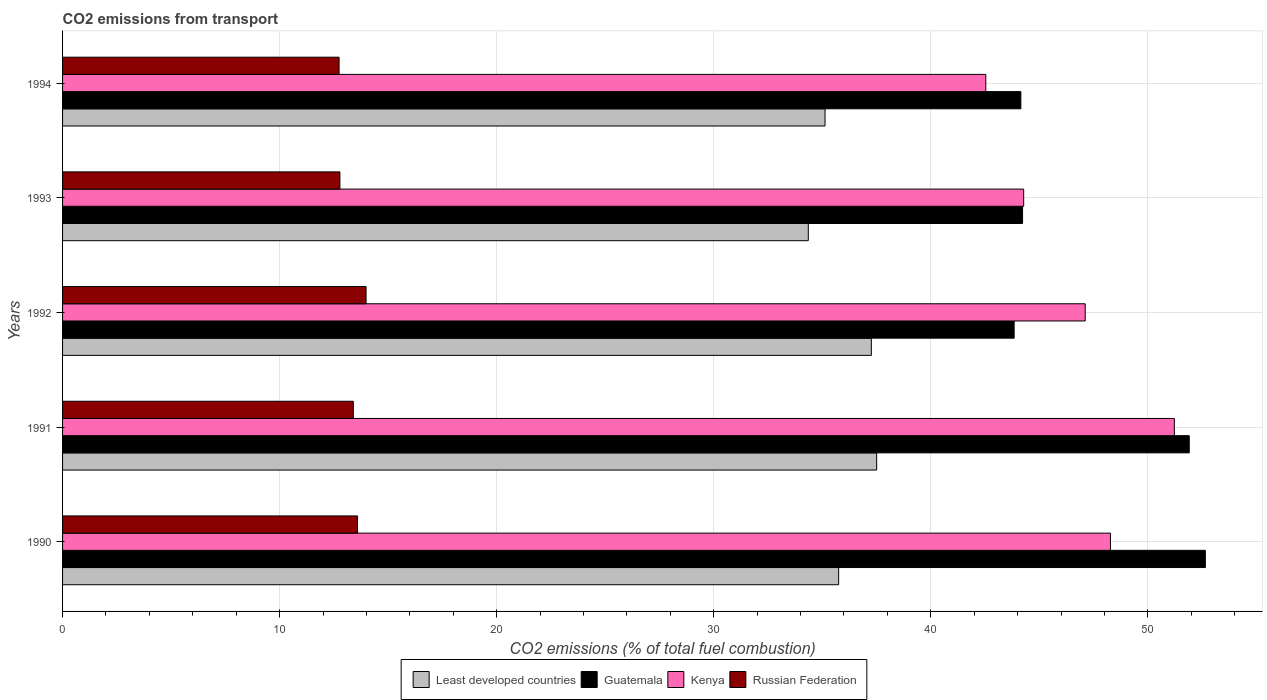How many bars are there on the 1st tick from the top?
Provide a succinct answer. 4. In how many cases, is the number of bars for a given year not equal to the number of legend labels?
Give a very brief answer. 0. What is the total CO2 emitted in Least developed countries in 1990?
Provide a succinct answer. 35.75. Across all years, what is the maximum total CO2 emitted in Guatemala?
Your answer should be compact. 52.65. Across all years, what is the minimum total CO2 emitted in Least developed countries?
Give a very brief answer. 34.36. What is the total total CO2 emitted in Guatemala in the graph?
Offer a terse response. 236.77. What is the difference between the total CO2 emitted in Russian Federation in 1991 and that in 1994?
Make the answer very short. 0.66. What is the difference between the total CO2 emitted in Guatemala in 1992 and the total CO2 emitted in Kenya in 1993?
Your response must be concise. -0.44. What is the average total CO2 emitted in Least developed countries per year?
Provide a short and direct response. 36. In the year 1994, what is the difference between the total CO2 emitted in Kenya and total CO2 emitted in Russian Federation?
Your response must be concise. 29.79. What is the ratio of the total CO2 emitted in Kenya in 1991 to that in 1993?
Offer a very short reply. 1.16. Is the difference between the total CO2 emitted in Kenya in 1990 and 1992 greater than the difference between the total CO2 emitted in Russian Federation in 1990 and 1992?
Your response must be concise. Yes. What is the difference between the highest and the second highest total CO2 emitted in Guatemala?
Keep it short and to the point. 0.74. What is the difference between the highest and the lowest total CO2 emitted in Kenya?
Your answer should be compact. 8.69. Is the sum of the total CO2 emitted in Russian Federation in 1991 and 1994 greater than the maximum total CO2 emitted in Guatemala across all years?
Your answer should be very brief. No. Is it the case that in every year, the sum of the total CO2 emitted in Russian Federation and total CO2 emitted in Least developed countries is greater than the sum of total CO2 emitted in Guatemala and total CO2 emitted in Kenya?
Keep it short and to the point. Yes. What does the 3rd bar from the top in 1990 represents?
Your answer should be compact. Guatemala. What does the 1st bar from the bottom in 1992 represents?
Make the answer very short. Least developed countries. Is it the case that in every year, the sum of the total CO2 emitted in Kenya and total CO2 emitted in Least developed countries is greater than the total CO2 emitted in Guatemala?
Your answer should be compact. Yes. How many bars are there?
Keep it short and to the point. 20. Are all the bars in the graph horizontal?
Give a very brief answer. Yes. What is the difference between two consecutive major ticks on the X-axis?
Make the answer very short. 10. Does the graph contain any zero values?
Make the answer very short. No. How many legend labels are there?
Provide a succinct answer. 4. What is the title of the graph?
Offer a terse response. CO2 emissions from transport. What is the label or title of the X-axis?
Your answer should be compact. CO2 emissions (% of total fuel combustion). What is the label or title of the Y-axis?
Provide a short and direct response. Years. What is the CO2 emissions (% of total fuel combustion) in Least developed countries in 1990?
Give a very brief answer. 35.75. What is the CO2 emissions (% of total fuel combustion) in Guatemala in 1990?
Offer a very short reply. 52.65. What is the CO2 emissions (% of total fuel combustion) of Kenya in 1990?
Your answer should be very brief. 48.28. What is the CO2 emissions (% of total fuel combustion) of Russian Federation in 1990?
Your response must be concise. 13.59. What is the CO2 emissions (% of total fuel combustion) in Least developed countries in 1991?
Make the answer very short. 37.51. What is the CO2 emissions (% of total fuel combustion) in Guatemala in 1991?
Provide a short and direct response. 51.91. What is the CO2 emissions (% of total fuel combustion) of Kenya in 1991?
Your answer should be very brief. 51.22. What is the CO2 emissions (% of total fuel combustion) of Russian Federation in 1991?
Offer a very short reply. 13.4. What is the CO2 emissions (% of total fuel combustion) of Least developed countries in 1992?
Give a very brief answer. 37.26. What is the CO2 emissions (% of total fuel combustion) in Guatemala in 1992?
Your response must be concise. 43.84. What is the CO2 emissions (% of total fuel combustion) in Kenya in 1992?
Provide a short and direct response. 47.11. What is the CO2 emissions (% of total fuel combustion) of Russian Federation in 1992?
Keep it short and to the point. 13.98. What is the CO2 emissions (% of total fuel combustion) of Least developed countries in 1993?
Make the answer very short. 34.36. What is the CO2 emissions (% of total fuel combustion) of Guatemala in 1993?
Your answer should be compact. 44.23. What is the CO2 emissions (% of total fuel combustion) in Kenya in 1993?
Keep it short and to the point. 44.28. What is the CO2 emissions (% of total fuel combustion) of Russian Federation in 1993?
Your response must be concise. 12.78. What is the CO2 emissions (% of total fuel combustion) in Least developed countries in 1994?
Offer a terse response. 35.13. What is the CO2 emissions (% of total fuel combustion) in Guatemala in 1994?
Your answer should be compact. 44.15. What is the CO2 emissions (% of total fuel combustion) of Kenya in 1994?
Make the answer very short. 42.53. What is the CO2 emissions (% of total fuel combustion) of Russian Federation in 1994?
Offer a terse response. 12.74. Across all years, what is the maximum CO2 emissions (% of total fuel combustion) of Least developed countries?
Your answer should be very brief. 37.51. Across all years, what is the maximum CO2 emissions (% of total fuel combustion) of Guatemala?
Offer a very short reply. 52.65. Across all years, what is the maximum CO2 emissions (% of total fuel combustion) in Kenya?
Provide a short and direct response. 51.22. Across all years, what is the maximum CO2 emissions (% of total fuel combustion) of Russian Federation?
Give a very brief answer. 13.98. Across all years, what is the minimum CO2 emissions (% of total fuel combustion) in Least developed countries?
Provide a short and direct response. 34.36. Across all years, what is the minimum CO2 emissions (% of total fuel combustion) of Guatemala?
Make the answer very short. 43.84. Across all years, what is the minimum CO2 emissions (% of total fuel combustion) in Kenya?
Offer a very short reply. 42.53. Across all years, what is the minimum CO2 emissions (% of total fuel combustion) in Russian Federation?
Ensure brevity in your answer.  12.74. What is the total CO2 emissions (% of total fuel combustion) in Least developed countries in the graph?
Your answer should be very brief. 180. What is the total CO2 emissions (% of total fuel combustion) in Guatemala in the graph?
Provide a short and direct response. 236.77. What is the total CO2 emissions (% of total fuel combustion) in Kenya in the graph?
Offer a very short reply. 233.42. What is the total CO2 emissions (% of total fuel combustion) in Russian Federation in the graph?
Your answer should be very brief. 66.48. What is the difference between the CO2 emissions (% of total fuel combustion) of Least developed countries in 1990 and that in 1991?
Your answer should be very brief. -1.75. What is the difference between the CO2 emissions (% of total fuel combustion) of Guatemala in 1990 and that in 1991?
Keep it short and to the point. 0.74. What is the difference between the CO2 emissions (% of total fuel combustion) of Kenya in 1990 and that in 1991?
Your answer should be compact. -2.94. What is the difference between the CO2 emissions (% of total fuel combustion) of Russian Federation in 1990 and that in 1991?
Offer a terse response. 0.19. What is the difference between the CO2 emissions (% of total fuel combustion) in Least developed countries in 1990 and that in 1992?
Offer a terse response. -1.51. What is the difference between the CO2 emissions (% of total fuel combustion) in Guatemala in 1990 and that in 1992?
Your answer should be very brief. 8.81. What is the difference between the CO2 emissions (% of total fuel combustion) in Kenya in 1990 and that in 1992?
Your answer should be compact. 1.16. What is the difference between the CO2 emissions (% of total fuel combustion) of Russian Federation in 1990 and that in 1992?
Give a very brief answer. -0.39. What is the difference between the CO2 emissions (% of total fuel combustion) in Least developed countries in 1990 and that in 1993?
Your answer should be compact. 1.4. What is the difference between the CO2 emissions (% of total fuel combustion) in Guatemala in 1990 and that in 1993?
Your answer should be very brief. 8.42. What is the difference between the CO2 emissions (% of total fuel combustion) of Kenya in 1990 and that in 1993?
Your answer should be very brief. 4. What is the difference between the CO2 emissions (% of total fuel combustion) of Russian Federation in 1990 and that in 1993?
Keep it short and to the point. 0.81. What is the difference between the CO2 emissions (% of total fuel combustion) in Least developed countries in 1990 and that in 1994?
Offer a very short reply. 0.63. What is the difference between the CO2 emissions (% of total fuel combustion) in Guatemala in 1990 and that in 1994?
Make the answer very short. 8.5. What is the difference between the CO2 emissions (% of total fuel combustion) of Kenya in 1990 and that in 1994?
Make the answer very short. 5.74. What is the difference between the CO2 emissions (% of total fuel combustion) of Russian Federation in 1990 and that in 1994?
Give a very brief answer. 0.85. What is the difference between the CO2 emissions (% of total fuel combustion) in Least developed countries in 1991 and that in 1992?
Give a very brief answer. 0.24. What is the difference between the CO2 emissions (% of total fuel combustion) of Guatemala in 1991 and that in 1992?
Ensure brevity in your answer.  8.07. What is the difference between the CO2 emissions (% of total fuel combustion) of Kenya in 1991 and that in 1992?
Offer a terse response. 4.11. What is the difference between the CO2 emissions (% of total fuel combustion) in Russian Federation in 1991 and that in 1992?
Offer a terse response. -0.59. What is the difference between the CO2 emissions (% of total fuel combustion) of Least developed countries in 1991 and that in 1993?
Keep it short and to the point. 3.15. What is the difference between the CO2 emissions (% of total fuel combustion) in Guatemala in 1991 and that in 1993?
Your response must be concise. 7.68. What is the difference between the CO2 emissions (% of total fuel combustion) in Kenya in 1991 and that in 1993?
Make the answer very short. 6.94. What is the difference between the CO2 emissions (% of total fuel combustion) in Russian Federation in 1991 and that in 1993?
Provide a short and direct response. 0.62. What is the difference between the CO2 emissions (% of total fuel combustion) in Least developed countries in 1991 and that in 1994?
Provide a short and direct response. 2.38. What is the difference between the CO2 emissions (% of total fuel combustion) of Guatemala in 1991 and that in 1994?
Your answer should be compact. 7.76. What is the difference between the CO2 emissions (% of total fuel combustion) of Kenya in 1991 and that in 1994?
Make the answer very short. 8.69. What is the difference between the CO2 emissions (% of total fuel combustion) of Russian Federation in 1991 and that in 1994?
Offer a terse response. 0.66. What is the difference between the CO2 emissions (% of total fuel combustion) in Least developed countries in 1992 and that in 1993?
Offer a very short reply. 2.91. What is the difference between the CO2 emissions (% of total fuel combustion) of Guatemala in 1992 and that in 1993?
Provide a succinct answer. -0.39. What is the difference between the CO2 emissions (% of total fuel combustion) of Kenya in 1992 and that in 1993?
Provide a short and direct response. 2.84. What is the difference between the CO2 emissions (% of total fuel combustion) in Russian Federation in 1992 and that in 1993?
Keep it short and to the point. 1.21. What is the difference between the CO2 emissions (% of total fuel combustion) of Least developed countries in 1992 and that in 1994?
Offer a terse response. 2.13. What is the difference between the CO2 emissions (% of total fuel combustion) in Guatemala in 1992 and that in 1994?
Your answer should be very brief. -0.31. What is the difference between the CO2 emissions (% of total fuel combustion) of Kenya in 1992 and that in 1994?
Your answer should be very brief. 4.58. What is the difference between the CO2 emissions (% of total fuel combustion) in Russian Federation in 1992 and that in 1994?
Your answer should be very brief. 1.24. What is the difference between the CO2 emissions (% of total fuel combustion) in Least developed countries in 1993 and that in 1994?
Offer a very short reply. -0.77. What is the difference between the CO2 emissions (% of total fuel combustion) of Guatemala in 1993 and that in 1994?
Keep it short and to the point. 0.08. What is the difference between the CO2 emissions (% of total fuel combustion) of Kenya in 1993 and that in 1994?
Provide a succinct answer. 1.74. What is the difference between the CO2 emissions (% of total fuel combustion) in Russian Federation in 1993 and that in 1994?
Provide a succinct answer. 0.04. What is the difference between the CO2 emissions (% of total fuel combustion) of Least developed countries in 1990 and the CO2 emissions (% of total fuel combustion) of Guatemala in 1991?
Offer a terse response. -16.15. What is the difference between the CO2 emissions (% of total fuel combustion) of Least developed countries in 1990 and the CO2 emissions (% of total fuel combustion) of Kenya in 1991?
Provide a succinct answer. -15.47. What is the difference between the CO2 emissions (% of total fuel combustion) of Least developed countries in 1990 and the CO2 emissions (% of total fuel combustion) of Russian Federation in 1991?
Make the answer very short. 22.36. What is the difference between the CO2 emissions (% of total fuel combustion) of Guatemala in 1990 and the CO2 emissions (% of total fuel combustion) of Kenya in 1991?
Provide a short and direct response. 1.43. What is the difference between the CO2 emissions (% of total fuel combustion) of Guatemala in 1990 and the CO2 emissions (% of total fuel combustion) of Russian Federation in 1991?
Give a very brief answer. 39.25. What is the difference between the CO2 emissions (% of total fuel combustion) of Kenya in 1990 and the CO2 emissions (% of total fuel combustion) of Russian Federation in 1991?
Offer a terse response. 34.88. What is the difference between the CO2 emissions (% of total fuel combustion) in Least developed countries in 1990 and the CO2 emissions (% of total fuel combustion) in Guatemala in 1992?
Provide a succinct answer. -8.09. What is the difference between the CO2 emissions (% of total fuel combustion) in Least developed countries in 1990 and the CO2 emissions (% of total fuel combustion) in Kenya in 1992?
Give a very brief answer. -11.36. What is the difference between the CO2 emissions (% of total fuel combustion) of Least developed countries in 1990 and the CO2 emissions (% of total fuel combustion) of Russian Federation in 1992?
Provide a short and direct response. 21.77. What is the difference between the CO2 emissions (% of total fuel combustion) of Guatemala in 1990 and the CO2 emissions (% of total fuel combustion) of Kenya in 1992?
Offer a terse response. 5.53. What is the difference between the CO2 emissions (% of total fuel combustion) of Guatemala in 1990 and the CO2 emissions (% of total fuel combustion) of Russian Federation in 1992?
Your response must be concise. 38.67. What is the difference between the CO2 emissions (% of total fuel combustion) in Kenya in 1990 and the CO2 emissions (% of total fuel combustion) in Russian Federation in 1992?
Offer a very short reply. 34.29. What is the difference between the CO2 emissions (% of total fuel combustion) in Least developed countries in 1990 and the CO2 emissions (% of total fuel combustion) in Guatemala in 1993?
Your response must be concise. -8.47. What is the difference between the CO2 emissions (% of total fuel combustion) of Least developed countries in 1990 and the CO2 emissions (% of total fuel combustion) of Kenya in 1993?
Your response must be concise. -8.52. What is the difference between the CO2 emissions (% of total fuel combustion) in Least developed countries in 1990 and the CO2 emissions (% of total fuel combustion) in Russian Federation in 1993?
Offer a very short reply. 22.98. What is the difference between the CO2 emissions (% of total fuel combustion) in Guatemala in 1990 and the CO2 emissions (% of total fuel combustion) in Kenya in 1993?
Your answer should be very brief. 8.37. What is the difference between the CO2 emissions (% of total fuel combustion) of Guatemala in 1990 and the CO2 emissions (% of total fuel combustion) of Russian Federation in 1993?
Offer a terse response. 39.87. What is the difference between the CO2 emissions (% of total fuel combustion) in Kenya in 1990 and the CO2 emissions (% of total fuel combustion) in Russian Federation in 1993?
Keep it short and to the point. 35.5. What is the difference between the CO2 emissions (% of total fuel combustion) of Least developed countries in 1990 and the CO2 emissions (% of total fuel combustion) of Guatemala in 1994?
Offer a terse response. -8.39. What is the difference between the CO2 emissions (% of total fuel combustion) in Least developed countries in 1990 and the CO2 emissions (% of total fuel combustion) in Kenya in 1994?
Your response must be concise. -6.78. What is the difference between the CO2 emissions (% of total fuel combustion) of Least developed countries in 1990 and the CO2 emissions (% of total fuel combustion) of Russian Federation in 1994?
Make the answer very short. 23.01. What is the difference between the CO2 emissions (% of total fuel combustion) of Guatemala in 1990 and the CO2 emissions (% of total fuel combustion) of Kenya in 1994?
Offer a terse response. 10.11. What is the difference between the CO2 emissions (% of total fuel combustion) in Guatemala in 1990 and the CO2 emissions (% of total fuel combustion) in Russian Federation in 1994?
Keep it short and to the point. 39.91. What is the difference between the CO2 emissions (% of total fuel combustion) of Kenya in 1990 and the CO2 emissions (% of total fuel combustion) of Russian Federation in 1994?
Give a very brief answer. 35.54. What is the difference between the CO2 emissions (% of total fuel combustion) of Least developed countries in 1991 and the CO2 emissions (% of total fuel combustion) of Guatemala in 1992?
Your response must be concise. -6.33. What is the difference between the CO2 emissions (% of total fuel combustion) in Least developed countries in 1991 and the CO2 emissions (% of total fuel combustion) in Kenya in 1992?
Keep it short and to the point. -9.61. What is the difference between the CO2 emissions (% of total fuel combustion) of Least developed countries in 1991 and the CO2 emissions (% of total fuel combustion) of Russian Federation in 1992?
Offer a terse response. 23.52. What is the difference between the CO2 emissions (% of total fuel combustion) in Guatemala in 1991 and the CO2 emissions (% of total fuel combustion) in Kenya in 1992?
Keep it short and to the point. 4.79. What is the difference between the CO2 emissions (% of total fuel combustion) of Guatemala in 1991 and the CO2 emissions (% of total fuel combustion) of Russian Federation in 1992?
Make the answer very short. 37.92. What is the difference between the CO2 emissions (% of total fuel combustion) in Kenya in 1991 and the CO2 emissions (% of total fuel combustion) in Russian Federation in 1992?
Offer a very short reply. 37.24. What is the difference between the CO2 emissions (% of total fuel combustion) of Least developed countries in 1991 and the CO2 emissions (% of total fuel combustion) of Guatemala in 1993?
Give a very brief answer. -6.72. What is the difference between the CO2 emissions (% of total fuel combustion) of Least developed countries in 1991 and the CO2 emissions (% of total fuel combustion) of Kenya in 1993?
Your answer should be very brief. -6.77. What is the difference between the CO2 emissions (% of total fuel combustion) of Least developed countries in 1991 and the CO2 emissions (% of total fuel combustion) of Russian Federation in 1993?
Give a very brief answer. 24.73. What is the difference between the CO2 emissions (% of total fuel combustion) of Guatemala in 1991 and the CO2 emissions (% of total fuel combustion) of Kenya in 1993?
Offer a terse response. 7.63. What is the difference between the CO2 emissions (% of total fuel combustion) in Guatemala in 1991 and the CO2 emissions (% of total fuel combustion) in Russian Federation in 1993?
Make the answer very short. 39.13. What is the difference between the CO2 emissions (% of total fuel combustion) of Kenya in 1991 and the CO2 emissions (% of total fuel combustion) of Russian Federation in 1993?
Keep it short and to the point. 38.44. What is the difference between the CO2 emissions (% of total fuel combustion) of Least developed countries in 1991 and the CO2 emissions (% of total fuel combustion) of Guatemala in 1994?
Provide a succinct answer. -6.64. What is the difference between the CO2 emissions (% of total fuel combustion) in Least developed countries in 1991 and the CO2 emissions (% of total fuel combustion) in Kenya in 1994?
Your answer should be very brief. -5.03. What is the difference between the CO2 emissions (% of total fuel combustion) in Least developed countries in 1991 and the CO2 emissions (% of total fuel combustion) in Russian Federation in 1994?
Provide a short and direct response. 24.77. What is the difference between the CO2 emissions (% of total fuel combustion) of Guatemala in 1991 and the CO2 emissions (% of total fuel combustion) of Kenya in 1994?
Your response must be concise. 9.37. What is the difference between the CO2 emissions (% of total fuel combustion) of Guatemala in 1991 and the CO2 emissions (% of total fuel combustion) of Russian Federation in 1994?
Your answer should be very brief. 39.17. What is the difference between the CO2 emissions (% of total fuel combustion) in Kenya in 1991 and the CO2 emissions (% of total fuel combustion) in Russian Federation in 1994?
Give a very brief answer. 38.48. What is the difference between the CO2 emissions (% of total fuel combustion) of Least developed countries in 1992 and the CO2 emissions (% of total fuel combustion) of Guatemala in 1993?
Offer a terse response. -6.97. What is the difference between the CO2 emissions (% of total fuel combustion) in Least developed countries in 1992 and the CO2 emissions (% of total fuel combustion) in Kenya in 1993?
Ensure brevity in your answer.  -7.02. What is the difference between the CO2 emissions (% of total fuel combustion) in Least developed countries in 1992 and the CO2 emissions (% of total fuel combustion) in Russian Federation in 1993?
Offer a very short reply. 24.48. What is the difference between the CO2 emissions (% of total fuel combustion) in Guatemala in 1992 and the CO2 emissions (% of total fuel combustion) in Kenya in 1993?
Your response must be concise. -0.44. What is the difference between the CO2 emissions (% of total fuel combustion) in Guatemala in 1992 and the CO2 emissions (% of total fuel combustion) in Russian Federation in 1993?
Make the answer very short. 31.06. What is the difference between the CO2 emissions (% of total fuel combustion) in Kenya in 1992 and the CO2 emissions (% of total fuel combustion) in Russian Federation in 1993?
Your answer should be very brief. 34.34. What is the difference between the CO2 emissions (% of total fuel combustion) in Least developed countries in 1992 and the CO2 emissions (% of total fuel combustion) in Guatemala in 1994?
Make the answer very short. -6.89. What is the difference between the CO2 emissions (% of total fuel combustion) in Least developed countries in 1992 and the CO2 emissions (% of total fuel combustion) in Kenya in 1994?
Provide a short and direct response. -5.27. What is the difference between the CO2 emissions (% of total fuel combustion) in Least developed countries in 1992 and the CO2 emissions (% of total fuel combustion) in Russian Federation in 1994?
Your answer should be compact. 24.52. What is the difference between the CO2 emissions (% of total fuel combustion) in Guatemala in 1992 and the CO2 emissions (% of total fuel combustion) in Kenya in 1994?
Your answer should be compact. 1.31. What is the difference between the CO2 emissions (% of total fuel combustion) in Guatemala in 1992 and the CO2 emissions (% of total fuel combustion) in Russian Federation in 1994?
Provide a short and direct response. 31.1. What is the difference between the CO2 emissions (% of total fuel combustion) of Kenya in 1992 and the CO2 emissions (% of total fuel combustion) of Russian Federation in 1994?
Provide a short and direct response. 34.37. What is the difference between the CO2 emissions (% of total fuel combustion) of Least developed countries in 1993 and the CO2 emissions (% of total fuel combustion) of Guatemala in 1994?
Make the answer very short. -9.79. What is the difference between the CO2 emissions (% of total fuel combustion) in Least developed countries in 1993 and the CO2 emissions (% of total fuel combustion) in Kenya in 1994?
Your response must be concise. -8.18. What is the difference between the CO2 emissions (% of total fuel combustion) of Least developed countries in 1993 and the CO2 emissions (% of total fuel combustion) of Russian Federation in 1994?
Ensure brevity in your answer.  21.62. What is the difference between the CO2 emissions (% of total fuel combustion) of Guatemala in 1993 and the CO2 emissions (% of total fuel combustion) of Kenya in 1994?
Ensure brevity in your answer.  1.69. What is the difference between the CO2 emissions (% of total fuel combustion) in Guatemala in 1993 and the CO2 emissions (% of total fuel combustion) in Russian Federation in 1994?
Make the answer very short. 31.49. What is the difference between the CO2 emissions (% of total fuel combustion) of Kenya in 1993 and the CO2 emissions (% of total fuel combustion) of Russian Federation in 1994?
Keep it short and to the point. 31.54. What is the average CO2 emissions (% of total fuel combustion) of Least developed countries per year?
Your answer should be compact. 36. What is the average CO2 emissions (% of total fuel combustion) in Guatemala per year?
Provide a succinct answer. 47.35. What is the average CO2 emissions (% of total fuel combustion) of Kenya per year?
Your answer should be compact. 46.68. What is the average CO2 emissions (% of total fuel combustion) in Russian Federation per year?
Give a very brief answer. 13.3. In the year 1990, what is the difference between the CO2 emissions (% of total fuel combustion) in Least developed countries and CO2 emissions (% of total fuel combustion) in Guatemala?
Ensure brevity in your answer.  -16.89. In the year 1990, what is the difference between the CO2 emissions (% of total fuel combustion) in Least developed countries and CO2 emissions (% of total fuel combustion) in Kenya?
Keep it short and to the point. -12.52. In the year 1990, what is the difference between the CO2 emissions (% of total fuel combustion) in Least developed countries and CO2 emissions (% of total fuel combustion) in Russian Federation?
Your answer should be compact. 22.16. In the year 1990, what is the difference between the CO2 emissions (% of total fuel combustion) of Guatemala and CO2 emissions (% of total fuel combustion) of Kenya?
Give a very brief answer. 4.37. In the year 1990, what is the difference between the CO2 emissions (% of total fuel combustion) in Guatemala and CO2 emissions (% of total fuel combustion) in Russian Federation?
Ensure brevity in your answer.  39.06. In the year 1990, what is the difference between the CO2 emissions (% of total fuel combustion) of Kenya and CO2 emissions (% of total fuel combustion) of Russian Federation?
Make the answer very short. 34.69. In the year 1991, what is the difference between the CO2 emissions (% of total fuel combustion) of Least developed countries and CO2 emissions (% of total fuel combustion) of Guatemala?
Ensure brevity in your answer.  -14.4. In the year 1991, what is the difference between the CO2 emissions (% of total fuel combustion) in Least developed countries and CO2 emissions (% of total fuel combustion) in Kenya?
Provide a short and direct response. -13.71. In the year 1991, what is the difference between the CO2 emissions (% of total fuel combustion) of Least developed countries and CO2 emissions (% of total fuel combustion) of Russian Federation?
Your answer should be very brief. 24.11. In the year 1991, what is the difference between the CO2 emissions (% of total fuel combustion) in Guatemala and CO2 emissions (% of total fuel combustion) in Kenya?
Provide a short and direct response. 0.69. In the year 1991, what is the difference between the CO2 emissions (% of total fuel combustion) of Guatemala and CO2 emissions (% of total fuel combustion) of Russian Federation?
Ensure brevity in your answer.  38.51. In the year 1991, what is the difference between the CO2 emissions (% of total fuel combustion) in Kenya and CO2 emissions (% of total fuel combustion) in Russian Federation?
Offer a very short reply. 37.82. In the year 1992, what is the difference between the CO2 emissions (% of total fuel combustion) of Least developed countries and CO2 emissions (% of total fuel combustion) of Guatemala?
Offer a terse response. -6.58. In the year 1992, what is the difference between the CO2 emissions (% of total fuel combustion) in Least developed countries and CO2 emissions (% of total fuel combustion) in Kenya?
Ensure brevity in your answer.  -9.85. In the year 1992, what is the difference between the CO2 emissions (% of total fuel combustion) of Least developed countries and CO2 emissions (% of total fuel combustion) of Russian Federation?
Give a very brief answer. 23.28. In the year 1992, what is the difference between the CO2 emissions (% of total fuel combustion) in Guatemala and CO2 emissions (% of total fuel combustion) in Kenya?
Offer a terse response. -3.27. In the year 1992, what is the difference between the CO2 emissions (% of total fuel combustion) in Guatemala and CO2 emissions (% of total fuel combustion) in Russian Federation?
Your answer should be very brief. 29.86. In the year 1992, what is the difference between the CO2 emissions (% of total fuel combustion) in Kenya and CO2 emissions (% of total fuel combustion) in Russian Federation?
Offer a terse response. 33.13. In the year 1993, what is the difference between the CO2 emissions (% of total fuel combustion) of Least developed countries and CO2 emissions (% of total fuel combustion) of Guatemala?
Provide a succinct answer. -9.87. In the year 1993, what is the difference between the CO2 emissions (% of total fuel combustion) in Least developed countries and CO2 emissions (% of total fuel combustion) in Kenya?
Your response must be concise. -9.92. In the year 1993, what is the difference between the CO2 emissions (% of total fuel combustion) in Least developed countries and CO2 emissions (% of total fuel combustion) in Russian Federation?
Ensure brevity in your answer.  21.58. In the year 1993, what is the difference between the CO2 emissions (% of total fuel combustion) of Guatemala and CO2 emissions (% of total fuel combustion) of Kenya?
Offer a terse response. -0.05. In the year 1993, what is the difference between the CO2 emissions (% of total fuel combustion) in Guatemala and CO2 emissions (% of total fuel combustion) in Russian Federation?
Offer a very short reply. 31.45. In the year 1993, what is the difference between the CO2 emissions (% of total fuel combustion) of Kenya and CO2 emissions (% of total fuel combustion) of Russian Federation?
Your response must be concise. 31.5. In the year 1994, what is the difference between the CO2 emissions (% of total fuel combustion) of Least developed countries and CO2 emissions (% of total fuel combustion) of Guatemala?
Your response must be concise. -9.02. In the year 1994, what is the difference between the CO2 emissions (% of total fuel combustion) in Least developed countries and CO2 emissions (% of total fuel combustion) in Kenya?
Your answer should be very brief. -7.41. In the year 1994, what is the difference between the CO2 emissions (% of total fuel combustion) in Least developed countries and CO2 emissions (% of total fuel combustion) in Russian Federation?
Keep it short and to the point. 22.39. In the year 1994, what is the difference between the CO2 emissions (% of total fuel combustion) in Guatemala and CO2 emissions (% of total fuel combustion) in Kenya?
Keep it short and to the point. 1.61. In the year 1994, what is the difference between the CO2 emissions (% of total fuel combustion) of Guatemala and CO2 emissions (% of total fuel combustion) of Russian Federation?
Keep it short and to the point. 31.41. In the year 1994, what is the difference between the CO2 emissions (% of total fuel combustion) in Kenya and CO2 emissions (% of total fuel combustion) in Russian Federation?
Your response must be concise. 29.79. What is the ratio of the CO2 emissions (% of total fuel combustion) of Least developed countries in 1990 to that in 1991?
Your answer should be compact. 0.95. What is the ratio of the CO2 emissions (% of total fuel combustion) of Guatemala in 1990 to that in 1991?
Provide a succinct answer. 1.01. What is the ratio of the CO2 emissions (% of total fuel combustion) in Kenya in 1990 to that in 1991?
Your answer should be compact. 0.94. What is the ratio of the CO2 emissions (% of total fuel combustion) of Russian Federation in 1990 to that in 1991?
Offer a terse response. 1.01. What is the ratio of the CO2 emissions (% of total fuel combustion) of Least developed countries in 1990 to that in 1992?
Your answer should be compact. 0.96. What is the ratio of the CO2 emissions (% of total fuel combustion) of Guatemala in 1990 to that in 1992?
Give a very brief answer. 1.2. What is the ratio of the CO2 emissions (% of total fuel combustion) of Kenya in 1990 to that in 1992?
Your response must be concise. 1.02. What is the ratio of the CO2 emissions (% of total fuel combustion) in Russian Federation in 1990 to that in 1992?
Your response must be concise. 0.97. What is the ratio of the CO2 emissions (% of total fuel combustion) of Least developed countries in 1990 to that in 1993?
Keep it short and to the point. 1.04. What is the ratio of the CO2 emissions (% of total fuel combustion) of Guatemala in 1990 to that in 1993?
Make the answer very short. 1.19. What is the ratio of the CO2 emissions (% of total fuel combustion) of Kenya in 1990 to that in 1993?
Keep it short and to the point. 1.09. What is the ratio of the CO2 emissions (% of total fuel combustion) of Russian Federation in 1990 to that in 1993?
Provide a short and direct response. 1.06. What is the ratio of the CO2 emissions (% of total fuel combustion) in Least developed countries in 1990 to that in 1994?
Offer a terse response. 1.02. What is the ratio of the CO2 emissions (% of total fuel combustion) of Guatemala in 1990 to that in 1994?
Your response must be concise. 1.19. What is the ratio of the CO2 emissions (% of total fuel combustion) in Kenya in 1990 to that in 1994?
Keep it short and to the point. 1.14. What is the ratio of the CO2 emissions (% of total fuel combustion) in Russian Federation in 1990 to that in 1994?
Offer a terse response. 1.07. What is the ratio of the CO2 emissions (% of total fuel combustion) of Least developed countries in 1991 to that in 1992?
Keep it short and to the point. 1.01. What is the ratio of the CO2 emissions (% of total fuel combustion) in Guatemala in 1991 to that in 1992?
Make the answer very short. 1.18. What is the ratio of the CO2 emissions (% of total fuel combustion) of Kenya in 1991 to that in 1992?
Make the answer very short. 1.09. What is the ratio of the CO2 emissions (% of total fuel combustion) in Russian Federation in 1991 to that in 1992?
Offer a terse response. 0.96. What is the ratio of the CO2 emissions (% of total fuel combustion) of Least developed countries in 1991 to that in 1993?
Provide a short and direct response. 1.09. What is the ratio of the CO2 emissions (% of total fuel combustion) of Guatemala in 1991 to that in 1993?
Your response must be concise. 1.17. What is the ratio of the CO2 emissions (% of total fuel combustion) in Kenya in 1991 to that in 1993?
Your answer should be compact. 1.16. What is the ratio of the CO2 emissions (% of total fuel combustion) of Russian Federation in 1991 to that in 1993?
Make the answer very short. 1.05. What is the ratio of the CO2 emissions (% of total fuel combustion) of Least developed countries in 1991 to that in 1994?
Make the answer very short. 1.07. What is the ratio of the CO2 emissions (% of total fuel combustion) in Guatemala in 1991 to that in 1994?
Ensure brevity in your answer.  1.18. What is the ratio of the CO2 emissions (% of total fuel combustion) in Kenya in 1991 to that in 1994?
Offer a terse response. 1.2. What is the ratio of the CO2 emissions (% of total fuel combustion) of Russian Federation in 1991 to that in 1994?
Your answer should be compact. 1.05. What is the ratio of the CO2 emissions (% of total fuel combustion) in Least developed countries in 1992 to that in 1993?
Provide a succinct answer. 1.08. What is the ratio of the CO2 emissions (% of total fuel combustion) in Kenya in 1992 to that in 1993?
Provide a succinct answer. 1.06. What is the ratio of the CO2 emissions (% of total fuel combustion) in Russian Federation in 1992 to that in 1993?
Offer a very short reply. 1.09. What is the ratio of the CO2 emissions (% of total fuel combustion) in Least developed countries in 1992 to that in 1994?
Your answer should be compact. 1.06. What is the ratio of the CO2 emissions (% of total fuel combustion) of Guatemala in 1992 to that in 1994?
Your answer should be compact. 0.99. What is the ratio of the CO2 emissions (% of total fuel combustion) of Kenya in 1992 to that in 1994?
Offer a terse response. 1.11. What is the ratio of the CO2 emissions (% of total fuel combustion) in Russian Federation in 1992 to that in 1994?
Your response must be concise. 1.1. What is the ratio of the CO2 emissions (% of total fuel combustion) of Kenya in 1993 to that in 1994?
Your answer should be compact. 1.04. What is the difference between the highest and the second highest CO2 emissions (% of total fuel combustion) in Least developed countries?
Provide a short and direct response. 0.24. What is the difference between the highest and the second highest CO2 emissions (% of total fuel combustion) in Guatemala?
Keep it short and to the point. 0.74. What is the difference between the highest and the second highest CO2 emissions (% of total fuel combustion) of Kenya?
Provide a short and direct response. 2.94. What is the difference between the highest and the second highest CO2 emissions (% of total fuel combustion) of Russian Federation?
Provide a short and direct response. 0.39. What is the difference between the highest and the lowest CO2 emissions (% of total fuel combustion) in Least developed countries?
Your answer should be compact. 3.15. What is the difference between the highest and the lowest CO2 emissions (% of total fuel combustion) in Guatemala?
Make the answer very short. 8.81. What is the difference between the highest and the lowest CO2 emissions (% of total fuel combustion) of Kenya?
Ensure brevity in your answer.  8.69. What is the difference between the highest and the lowest CO2 emissions (% of total fuel combustion) in Russian Federation?
Offer a terse response. 1.24. 